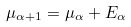<formula> <loc_0><loc_0><loc_500><loc_500>\mu _ { \alpha + 1 } = \mu _ { \alpha } + E _ { \alpha }</formula> 